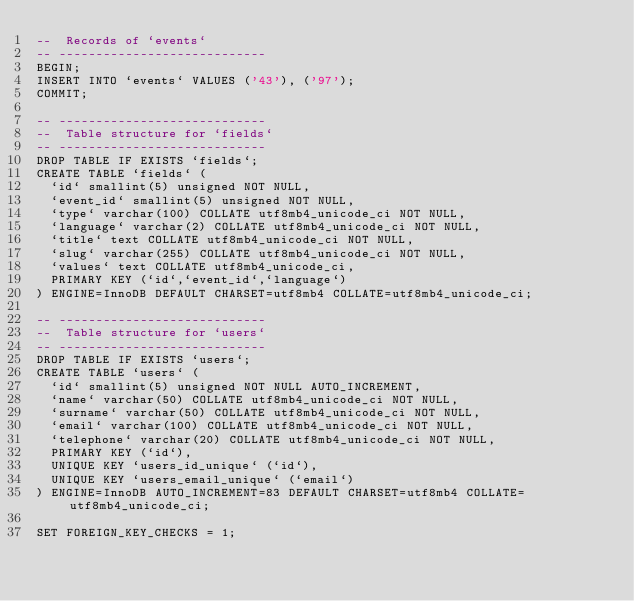<code> <loc_0><loc_0><loc_500><loc_500><_SQL_>--  Records of `events`
-- ----------------------------
BEGIN;
INSERT INTO `events` VALUES ('43'), ('97');
COMMIT;

-- ----------------------------
--  Table structure for `fields`
-- ----------------------------
DROP TABLE IF EXISTS `fields`;
CREATE TABLE `fields` (
  `id` smallint(5) unsigned NOT NULL,
  `event_id` smallint(5) unsigned NOT NULL,
  `type` varchar(100) COLLATE utf8mb4_unicode_ci NOT NULL,
  `language` varchar(2) COLLATE utf8mb4_unicode_ci NOT NULL,
  `title` text COLLATE utf8mb4_unicode_ci NOT NULL,
  `slug` varchar(255) COLLATE utf8mb4_unicode_ci NOT NULL,
  `values` text COLLATE utf8mb4_unicode_ci,
  PRIMARY KEY (`id`,`event_id`,`language`)
) ENGINE=InnoDB DEFAULT CHARSET=utf8mb4 COLLATE=utf8mb4_unicode_ci;

-- ----------------------------
--  Table structure for `users`
-- ----------------------------
DROP TABLE IF EXISTS `users`;
CREATE TABLE `users` (
  `id` smallint(5) unsigned NOT NULL AUTO_INCREMENT,
  `name` varchar(50) COLLATE utf8mb4_unicode_ci NOT NULL,
  `surname` varchar(50) COLLATE utf8mb4_unicode_ci NOT NULL,
  `email` varchar(100) COLLATE utf8mb4_unicode_ci NOT NULL,
  `telephone` varchar(20) COLLATE utf8mb4_unicode_ci NOT NULL,
  PRIMARY KEY (`id`),
  UNIQUE KEY `users_id_unique` (`id`),
  UNIQUE KEY `users_email_unique` (`email`)
) ENGINE=InnoDB AUTO_INCREMENT=83 DEFAULT CHARSET=utf8mb4 COLLATE=utf8mb4_unicode_ci;

SET FOREIGN_KEY_CHECKS = 1;
</code> 